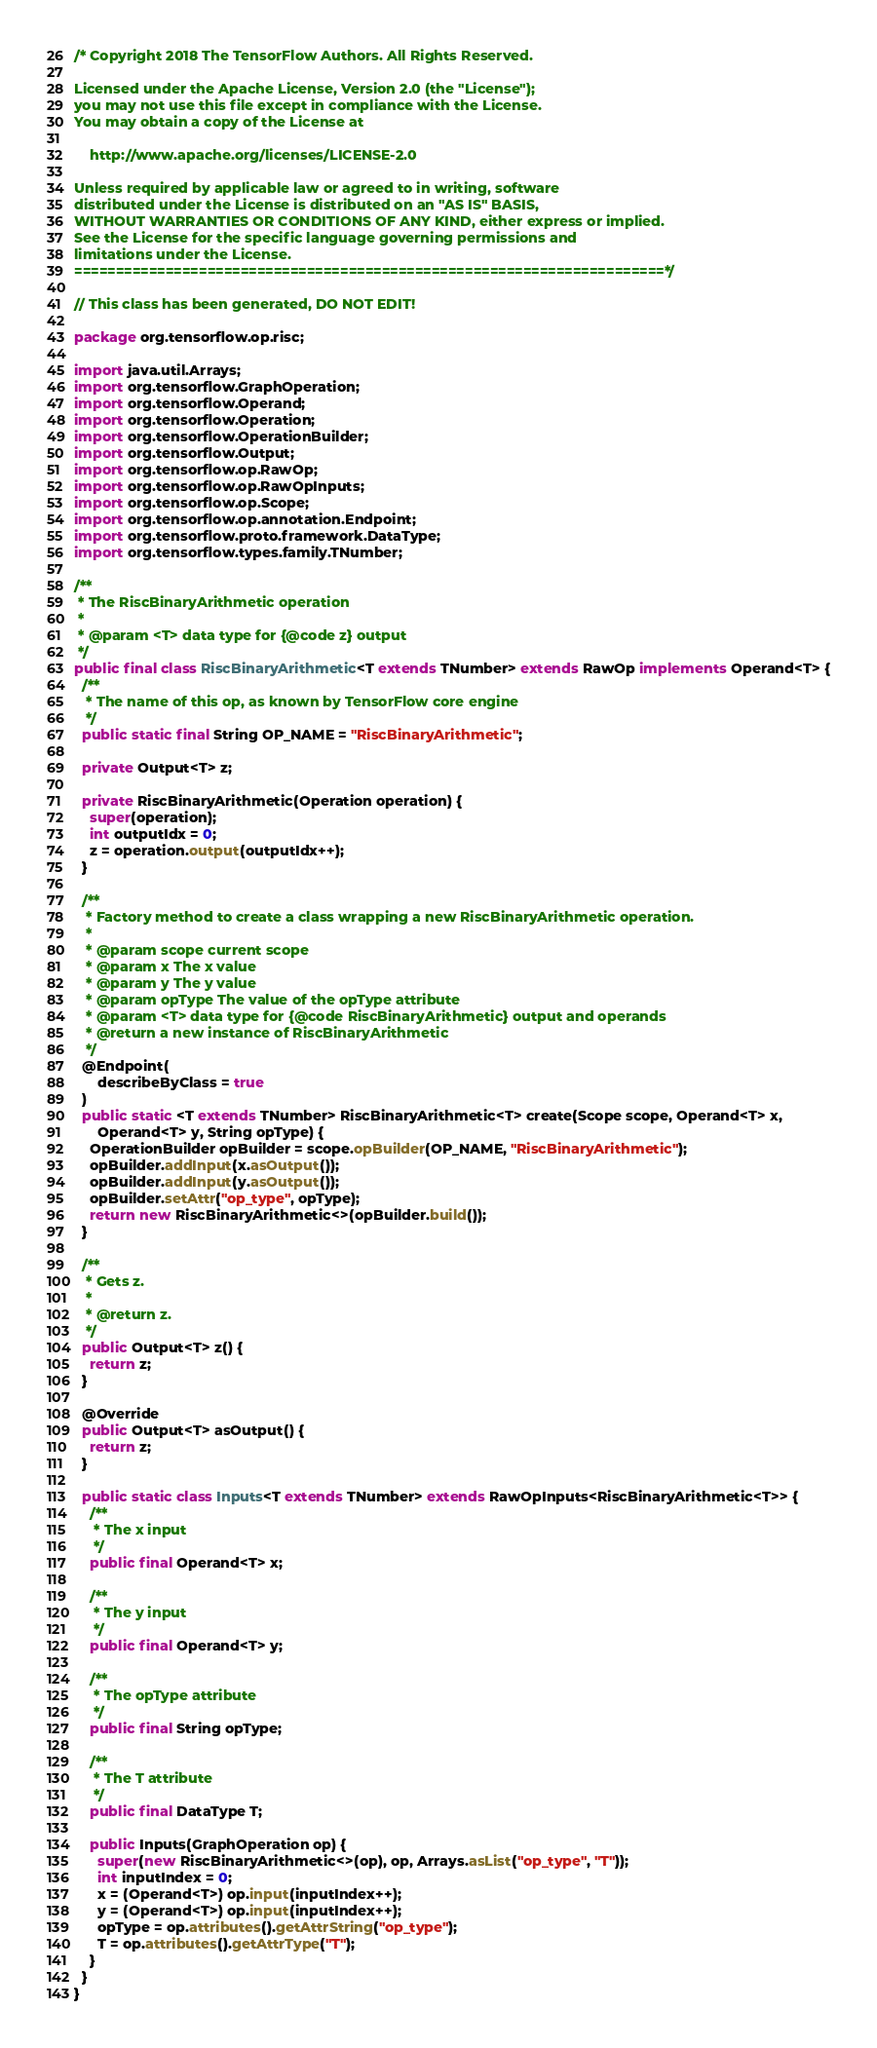<code> <loc_0><loc_0><loc_500><loc_500><_Java_>/* Copyright 2018 The TensorFlow Authors. All Rights Reserved.

Licensed under the Apache License, Version 2.0 (the "License");
you may not use this file except in compliance with the License.
You may obtain a copy of the License at

    http://www.apache.org/licenses/LICENSE-2.0

Unless required by applicable law or agreed to in writing, software
distributed under the License is distributed on an "AS IS" BASIS,
WITHOUT WARRANTIES OR CONDITIONS OF ANY KIND, either express or implied.
See the License for the specific language governing permissions and
limitations under the License.
=======================================================================*/

// This class has been generated, DO NOT EDIT!

package org.tensorflow.op.risc;

import java.util.Arrays;
import org.tensorflow.GraphOperation;
import org.tensorflow.Operand;
import org.tensorflow.Operation;
import org.tensorflow.OperationBuilder;
import org.tensorflow.Output;
import org.tensorflow.op.RawOp;
import org.tensorflow.op.RawOpInputs;
import org.tensorflow.op.Scope;
import org.tensorflow.op.annotation.Endpoint;
import org.tensorflow.proto.framework.DataType;
import org.tensorflow.types.family.TNumber;

/**
 * The RiscBinaryArithmetic operation
 *
 * @param <T> data type for {@code z} output
 */
public final class RiscBinaryArithmetic<T extends TNumber> extends RawOp implements Operand<T> {
  /**
   * The name of this op, as known by TensorFlow core engine
   */
  public static final String OP_NAME = "RiscBinaryArithmetic";

  private Output<T> z;

  private RiscBinaryArithmetic(Operation operation) {
    super(operation);
    int outputIdx = 0;
    z = operation.output(outputIdx++);
  }

  /**
   * Factory method to create a class wrapping a new RiscBinaryArithmetic operation.
   *
   * @param scope current scope
   * @param x The x value
   * @param y The y value
   * @param opType The value of the opType attribute
   * @param <T> data type for {@code RiscBinaryArithmetic} output and operands
   * @return a new instance of RiscBinaryArithmetic
   */
  @Endpoint(
      describeByClass = true
  )
  public static <T extends TNumber> RiscBinaryArithmetic<T> create(Scope scope, Operand<T> x,
      Operand<T> y, String opType) {
    OperationBuilder opBuilder = scope.opBuilder(OP_NAME, "RiscBinaryArithmetic");
    opBuilder.addInput(x.asOutput());
    opBuilder.addInput(y.asOutput());
    opBuilder.setAttr("op_type", opType);
    return new RiscBinaryArithmetic<>(opBuilder.build());
  }

  /**
   * Gets z.
   *
   * @return z.
   */
  public Output<T> z() {
    return z;
  }

  @Override
  public Output<T> asOutput() {
    return z;
  }

  public static class Inputs<T extends TNumber> extends RawOpInputs<RiscBinaryArithmetic<T>> {
    /**
     * The x input
     */
    public final Operand<T> x;

    /**
     * The y input
     */
    public final Operand<T> y;

    /**
     * The opType attribute
     */
    public final String opType;

    /**
     * The T attribute
     */
    public final DataType T;

    public Inputs(GraphOperation op) {
      super(new RiscBinaryArithmetic<>(op), op, Arrays.asList("op_type", "T"));
      int inputIndex = 0;
      x = (Operand<T>) op.input(inputIndex++);
      y = (Operand<T>) op.input(inputIndex++);
      opType = op.attributes().getAttrString("op_type");
      T = op.attributes().getAttrType("T");
    }
  }
}
</code> 